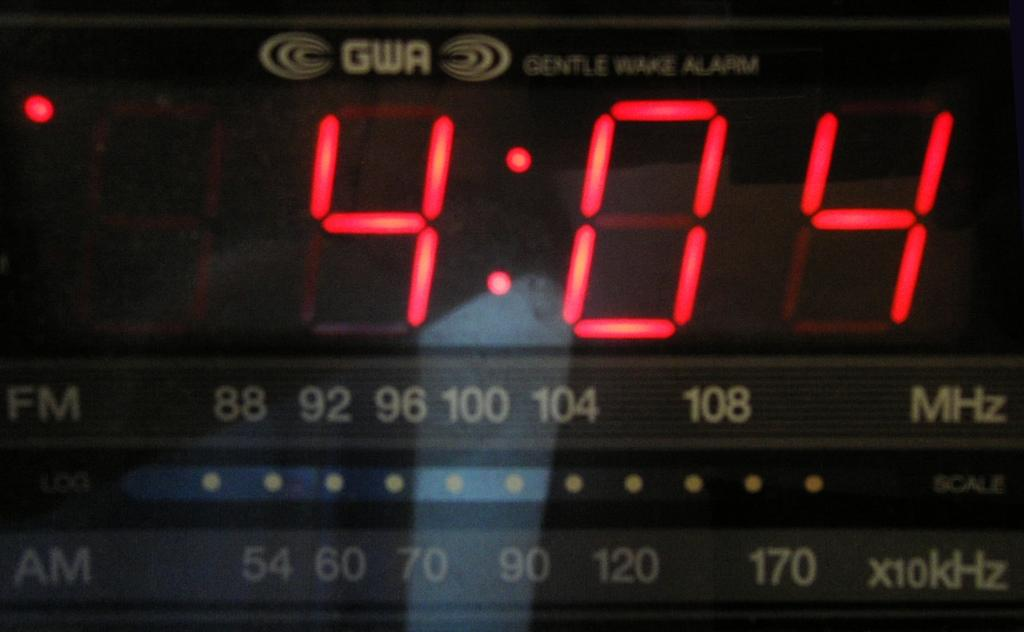<image>
Give a short and clear explanation of the subsequent image. A digital clock with a Gentle Wake Alarm reads 4:04. 